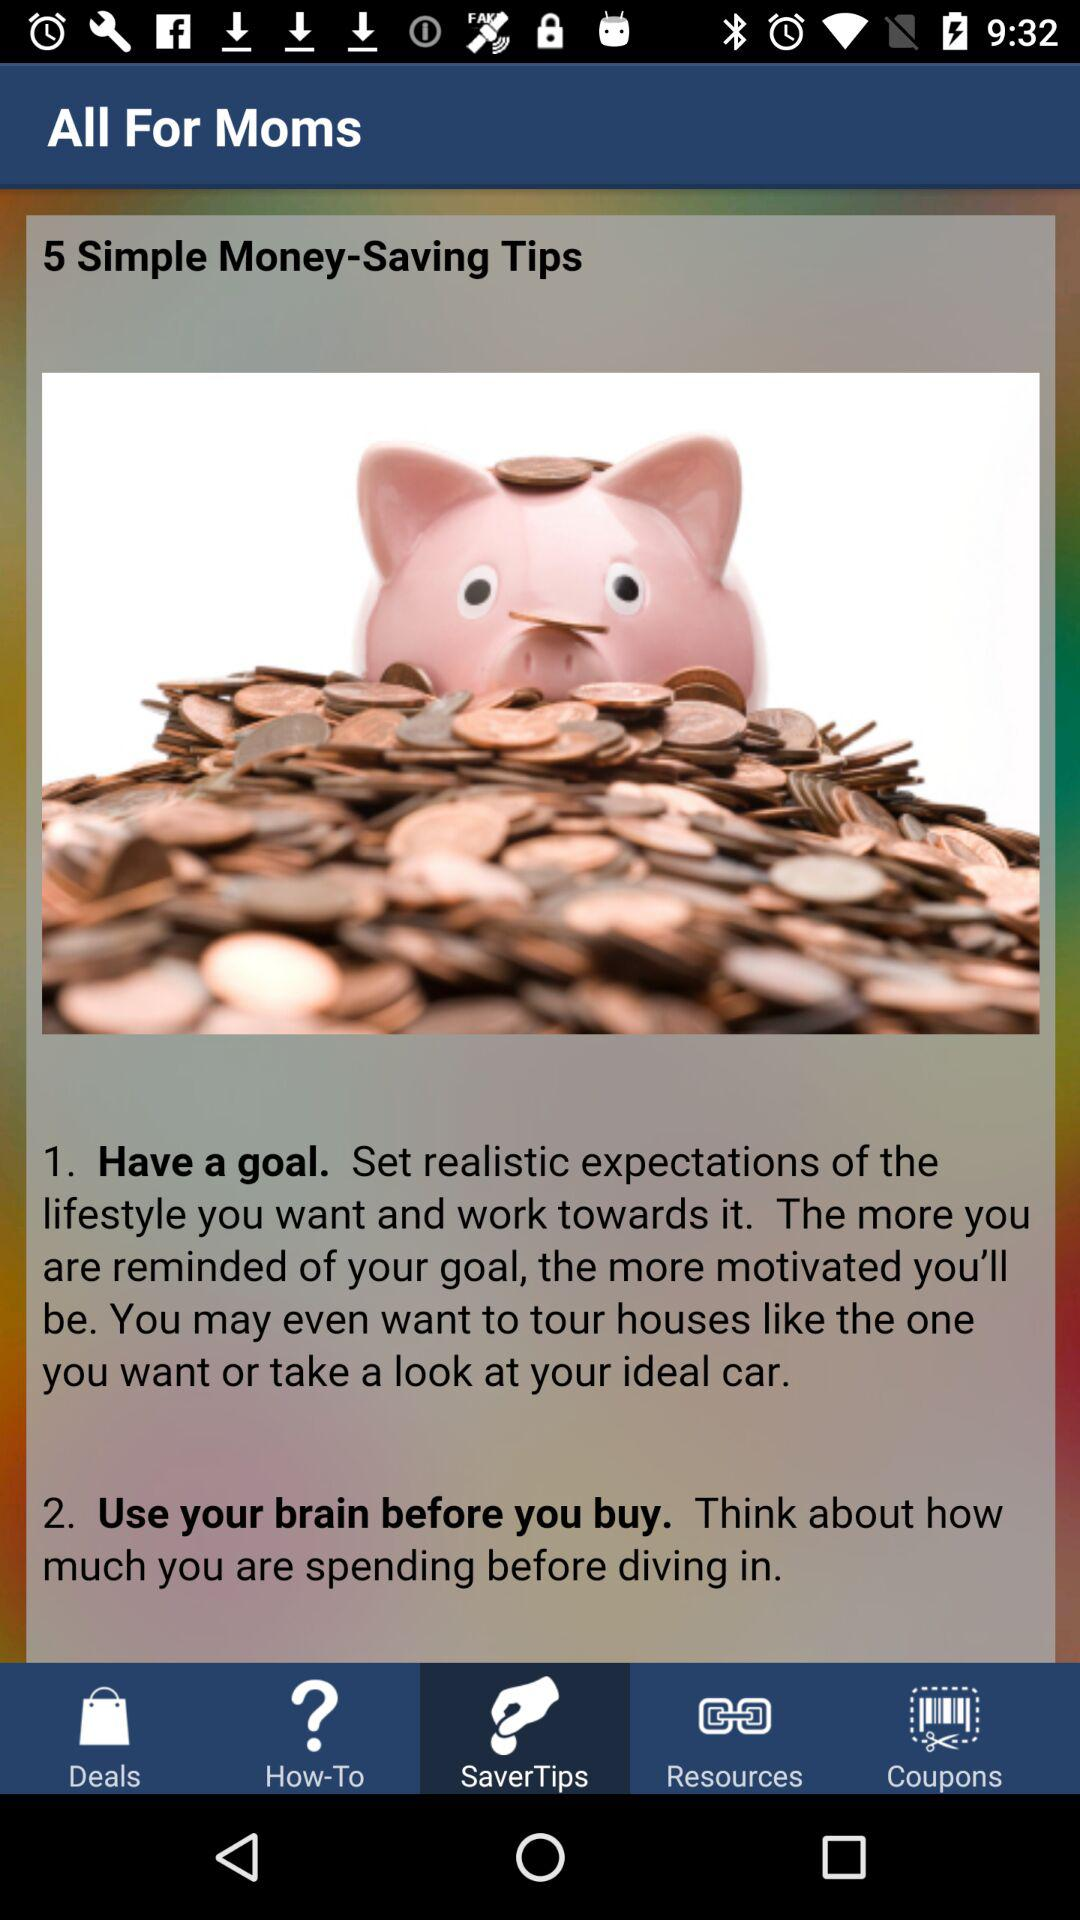What is the second thing that you should do to save money? The second thing that you should do to save money is "Use your brain before you buy.". 